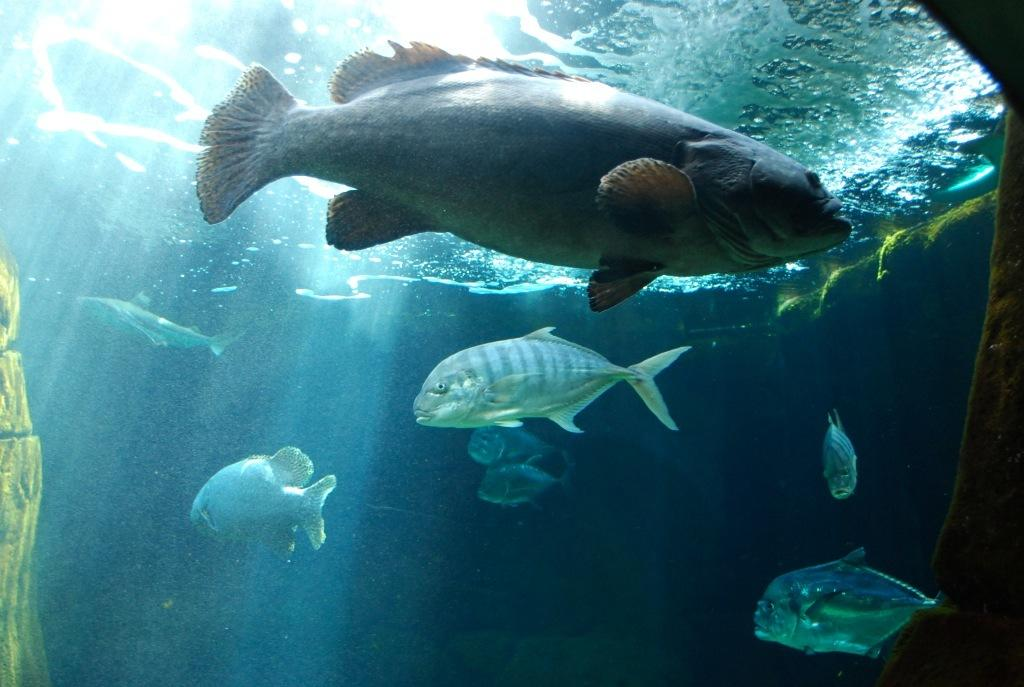What type of animals are in the image? There are fishes in the image. Where are the fishes located? The fishes are in the water. What type of mineral can be seen in the image? There is no mineral present in the image; it features fishes in the water. How many people are in the crowd in the image? There is no crowd present in the image; it features fishes in the water. 